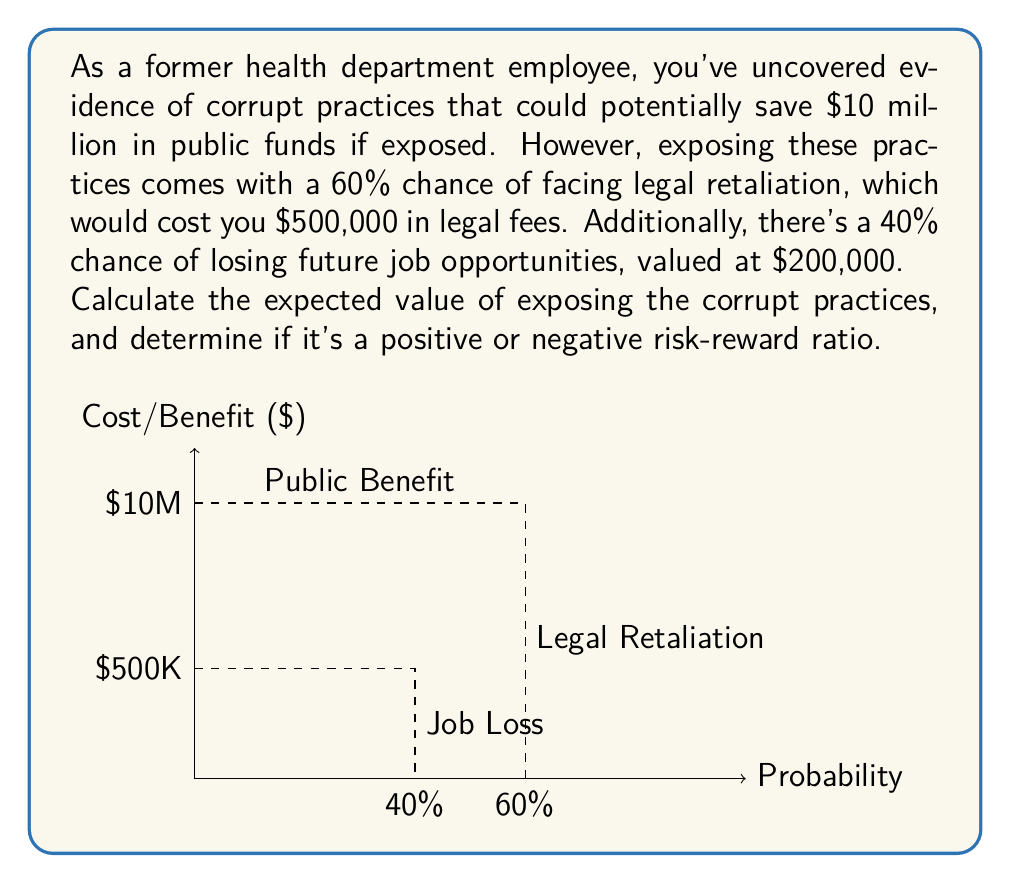Teach me how to tackle this problem. Let's break this down step-by-step:

1) First, we need to calculate the expected costs:

   a) Legal retaliation: 
      Probability = 60% = 0.6
      Cost = $500,000
      Expected cost = $500,000 * 0.6 = $300,000

   b) Job loss: 
      Probability = 40% = 0.4
      Cost = $200,000
      Expected cost = $200,000 * 0.4 = $80,000

2) Total expected cost:
   $300,000 + $80,000 = $380,000

3) The benefit is the $10 million in public funds saved.

4) To calculate the expected value, we subtract the expected costs from the benefit:

   Expected Value = Benefit - Expected Costs
   $$ EV = 10,000,000 - 380,000 = 9,620,000 $$

5) To determine if this is a positive or negative risk-reward ratio, we compare the expected value to zero:

   $9,620,000 > 0$, so this is a positive risk-reward ratio.

6) We can also calculate the exact risk-reward ratio:

   Risk-Reward Ratio = Benefit / Expected Costs
   $$ RR = \frac{10,000,000}{380,000} \approx 26.32 $$

   This means for every $1 of expected cost, there's a potential benefit of $26.32.
Answer: $9,620,000; positive ratio 